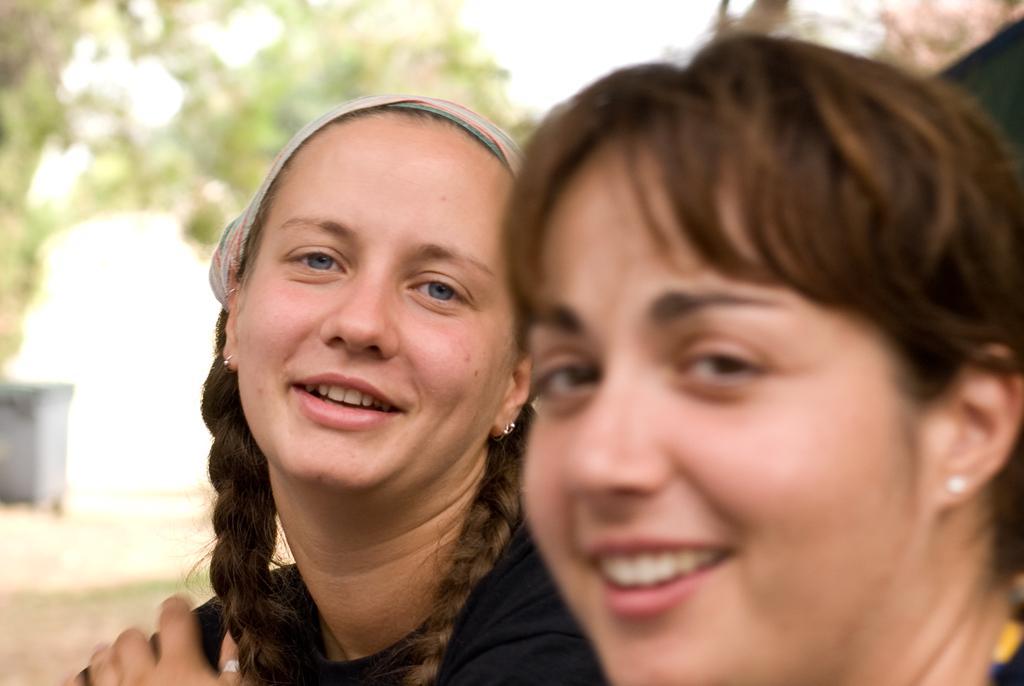In one or two sentences, can you explain what this image depicts? On the left side, there is a woman, smiling and watching something. On the right side, there is another woman, smiling and watching something. And the background is blurred. 